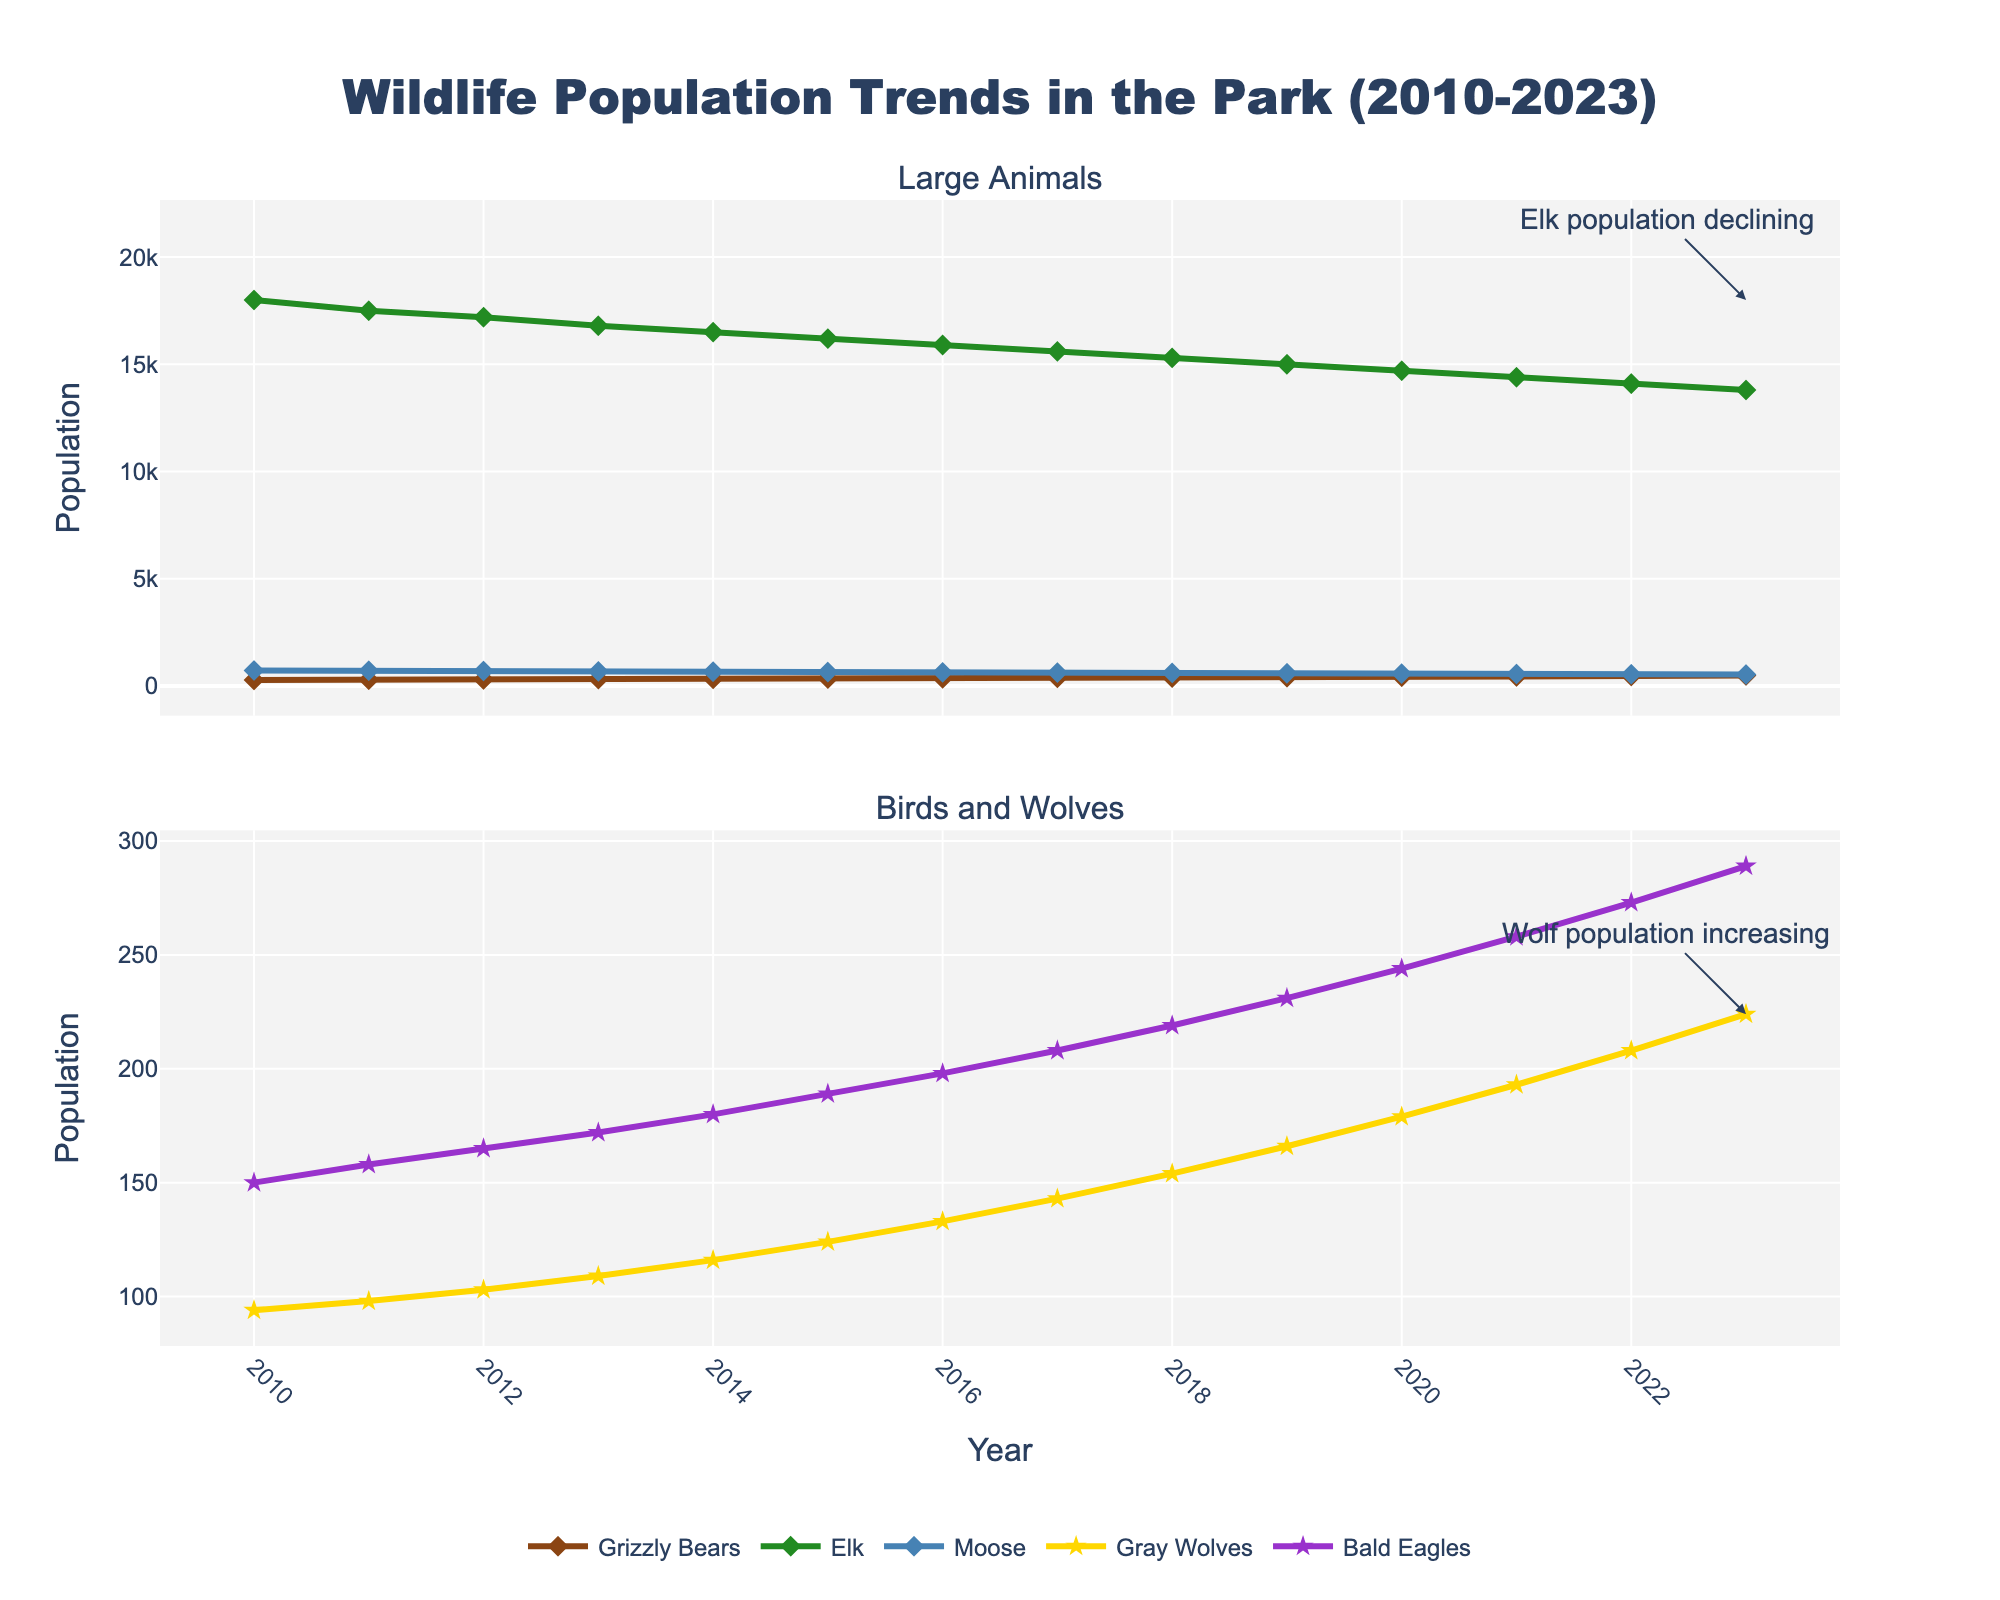What is the overall trend in the Grizzly Bear population from 2010 to 2023? The line for Grizzly Bears steadily rises from 2010 to 2023, indicating an upward trend. The population increases each year from 282 in 2010 to 487 in 2023.
Answer: Upward trend How does the population of Bald Eagles in 2023 compare to its population in 2010? In 2010, the Bald Eagle population was 150, and by 2023, it increased to 289. Thus, the Bald Eagle population increased over the period.
Answer: Increased Which species had a declining population trend from 2010 to 2023? By looking at all the lines, only the Elk population shows a consistent downward trend from 18000 in 2010 to 13800 in 2023.
Answer: Elk What is the difference in the Moose population between 2010 and 2023? The Moose population was 720 in 2010 and declined to 530 by 2023. The difference is 720 - 530 = 190.
Answer: 190 Which species saw the highest percentage increase in their population from 2010 to 2023? To answer this, we assess percentage changes: Grizzly Bears: (487-282)/282 ≈ 72.70%, Elk: (13800-18000)/18000 ≈ -23.33%, Gray Wolves: (224-94)/94 ≈ 138.30%, Bald Eagles: (289-150)/150 ≈ 92.67%, Moose: (530-720)/720 ≈ -26.39%. Gray Wolves had the highest percentage increase.
Answer: Gray Wolves Are there any years where the Elk population stabilized? The Elk population shows a noticeable decline each year, with no evident periods of stability. Hence, there are no years where the Elk population stabilized.
Answer: No What can be said about the population trend of the Gray Wolves from 2010 to 2023? The Gray Wolves show a consistent increase in population from 94 in 2010 to 224 in 2023, indicating an upward trend throughout this period.
Answer: Upward trend How do the trends in Grizzly Bears and Gray Wolves populations compare over the years? Both Grizzly Bears and Gray Wolves show an upward trend, but the Gray Wolves' population increase is steeper compared to that of the Grizzly Bears.
Answer: Both upward, Gray Wolves steeper What can be inferred about the park’s ecosystem health from the declining Elk population? The declining Elk population could suggest issues within the park's ecosystem, such as increased predation, habitat loss, or resource scarcity, which may indirectly affect other species and eco-tourism activities.
Answer: Indirect ecosystem issues Summarize the trends for large animals (Grizzly Bears, Elk, Moose) from 2010 to 2023. Grizzly Bears show a continuous increase, Elk exhibit a continuous decline, and Moose also demonstrate a declining trend throughout this period.
Answer: Grizzly Bears: increase, Elk: decline, Moose: decline 